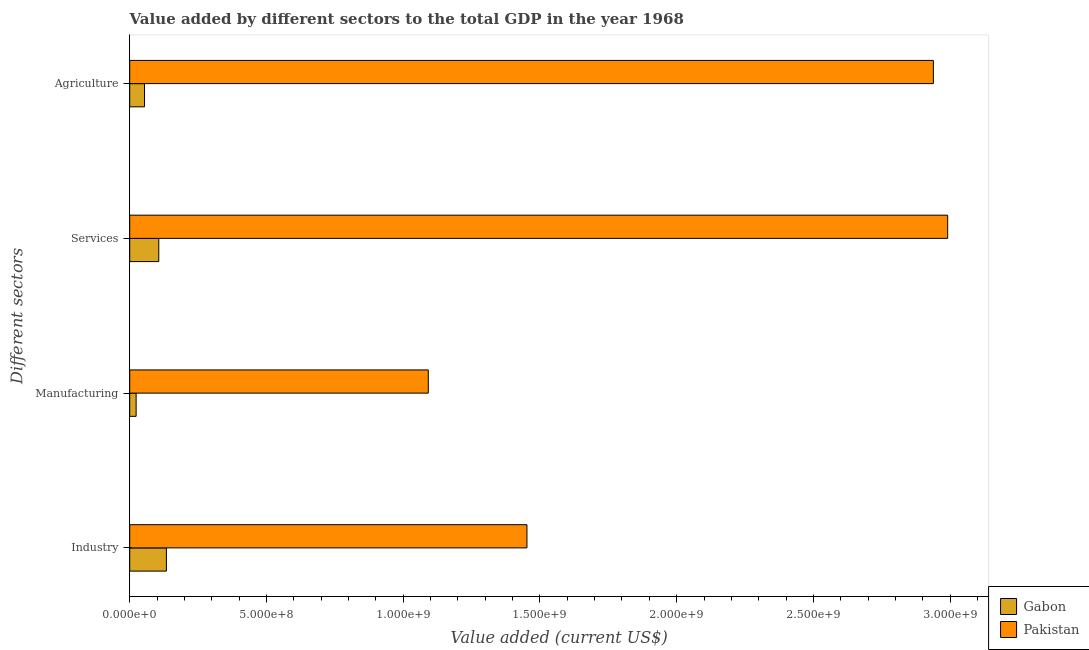How many different coloured bars are there?
Offer a very short reply. 2. Are the number of bars per tick equal to the number of legend labels?
Keep it short and to the point. Yes. Are the number of bars on each tick of the Y-axis equal?
Make the answer very short. Yes. How many bars are there on the 4th tick from the top?
Your answer should be compact. 2. How many bars are there on the 2nd tick from the bottom?
Provide a short and direct response. 2. What is the label of the 1st group of bars from the top?
Your answer should be compact. Agriculture. What is the value added by manufacturing sector in Pakistan?
Your answer should be compact. 1.09e+09. Across all countries, what is the maximum value added by agricultural sector?
Your answer should be compact. 2.94e+09. Across all countries, what is the minimum value added by manufacturing sector?
Provide a succinct answer. 2.34e+07. In which country was the value added by agricultural sector maximum?
Make the answer very short. Pakistan. In which country was the value added by agricultural sector minimum?
Provide a short and direct response. Gabon. What is the total value added by agricultural sector in the graph?
Offer a terse response. 2.99e+09. What is the difference between the value added by manufacturing sector in Gabon and that in Pakistan?
Provide a succinct answer. -1.07e+09. What is the difference between the value added by services sector in Gabon and the value added by industrial sector in Pakistan?
Provide a short and direct response. -1.35e+09. What is the average value added by services sector per country?
Make the answer very short. 1.55e+09. What is the difference between the value added by agricultural sector and value added by manufacturing sector in Gabon?
Provide a short and direct response. 3.07e+07. What is the ratio of the value added by services sector in Pakistan to that in Gabon?
Offer a very short reply. 28.15. Is the difference between the value added by industrial sector in Gabon and Pakistan greater than the difference between the value added by agricultural sector in Gabon and Pakistan?
Offer a terse response. Yes. What is the difference between the highest and the second highest value added by industrial sector?
Offer a terse response. 1.32e+09. What is the difference between the highest and the lowest value added by services sector?
Your answer should be very brief. 2.88e+09. In how many countries, is the value added by manufacturing sector greater than the average value added by manufacturing sector taken over all countries?
Ensure brevity in your answer.  1. What does the 2nd bar from the top in Manufacturing represents?
Provide a succinct answer. Gabon. What does the 2nd bar from the bottom in Industry represents?
Your answer should be compact. Pakistan. Is it the case that in every country, the sum of the value added by industrial sector and value added by manufacturing sector is greater than the value added by services sector?
Your answer should be very brief. No. How many countries are there in the graph?
Provide a short and direct response. 2. Does the graph contain any zero values?
Ensure brevity in your answer.  No. How many legend labels are there?
Offer a very short reply. 2. What is the title of the graph?
Provide a succinct answer. Value added by different sectors to the total GDP in the year 1968. What is the label or title of the X-axis?
Give a very brief answer. Value added (current US$). What is the label or title of the Y-axis?
Your answer should be compact. Different sectors. What is the Value added (current US$) in Gabon in Industry?
Keep it short and to the point. 1.34e+08. What is the Value added (current US$) of Pakistan in Industry?
Offer a very short reply. 1.45e+09. What is the Value added (current US$) of Gabon in Manufacturing?
Ensure brevity in your answer.  2.34e+07. What is the Value added (current US$) in Pakistan in Manufacturing?
Make the answer very short. 1.09e+09. What is the Value added (current US$) in Gabon in Services?
Keep it short and to the point. 1.06e+08. What is the Value added (current US$) of Pakistan in Services?
Ensure brevity in your answer.  2.99e+09. What is the Value added (current US$) of Gabon in Agriculture?
Provide a short and direct response. 5.41e+07. What is the Value added (current US$) of Pakistan in Agriculture?
Make the answer very short. 2.94e+09. Across all Different sectors, what is the maximum Value added (current US$) in Gabon?
Your response must be concise. 1.34e+08. Across all Different sectors, what is the maximum Value added (current US$) in Pakistan?
Your answer should be very brief. 2.99e+09. Across all Different sectors, what is the minimum Value added (current US$) of Gabon?
Make the answer very short. 2.34e+07. Across all Different sectors, what is the minimum Value added (current US$) in Pakistan?
Keep it short and to the point. 1.09e+09. What is the total Value added (current US$) in Gabon in the graph?
Offer a very short reply. 3.18e+08. What is the total Value added (current US$) in Pakistan in the graph?
Your answer should be very brief. 8.47e+09. What is the difference between the Value added (current US$) in Gabon in Industry and that in Manufacturing?
Your answer should be compact. 1.11e+08. What is the difference between the Value added (current US$) in Pakistan in Industry and that in Manufacturing?
Give a very brief answer. 3.61e+08. What is the difference between the Value added (current US$) in Gabon in Industry and that in Services?
Keep it short and to the point. 2.79e+07. What is the difference between the Value added (current US$) of Pakistan in Industry and that in Services?
Provide a short and direct response. -1.54e+09. What is the difference between the Value added (current US$) in Gabon in Industry and that in Agriculture?
Your answer should be very brief. 8.00e+07. What is the difference between the Value added (current US$) of Pakistan in Industry and that in Agriculture?
Provide a short and direct response. -1.49e+09. What is the difference between the Value added (current US$) of Gabon in Manufacturing and that in Services?
Keep it short and to the point. -8.28e+07. What is the difference between the Value added (current US$) of Pakistan in Manufacturing and that in Services?
Provide a succinct answer. -1.90e+09. What is the difference between the Value added (current US$) of Gabon in Manufacturing and that in Agriculture?
Provide a succinct answer. -3.07e+07. What is the difference between the Value added (current US$) in Pakistan in Manufacturing and that in Agriculture?
Provide a short and direct response. -1.85e+09. What is the difference between the Value added (current US$) of Gabon in Services and that in Agriculture?
Your answer should be compact. 5.21e+07. What is the difference between the Value added (current US$) in Pakistan in Services and that in Agriculture?
Provide a succinct answer. 5.23e+07. What is the difference between the Value added (current US$) in Gabon in Industry and the Value added (current US$) in Pakistan in Manufacturing?
Provide a short and direct response. -9.58e+08. What is the difference between the Value added (current US$) in Gabon in Industry and the Value added (current US$) in Pakistan in Services?
Your response must be concise. -2.86e+09. What is the difference between the Value added (current US$) in Gabon in Industry and the Value added (current US$) in Pakistan in Agriculture?
Your answer should be compact. -2.80e+09. What is the difference between the Value added (current US$) in Gabon in Manufacturing and the Value added (current US$) in Pakistan in Services?
Provide a succinct answer. -2.97e+09. What is the difference between the Value added (current US$) of Gabon in Manufacturing and the Value added (current US$) of Pakistan in Agriculture?
Make the answer very short. -2.92e+09. What is the difference between the Value added (current US$) in Gabon in Services and the Value added (current US$) in Pakistan in Agriculture?
Give a very brief answer. -2.83e+09. What is the average Value added (current US$) of Gabon per Different sectors?
Give a very brief answer. 7.95e+07. What is the average Value added (current US$) of Pakistan per Different sectors?
Keep it short and to the point. 2.12e+09. What is the difference between the Value added (current US$) in Gabon and Value added (current US$) in Pakistan in Industry?
Provide a succinct answer. -1.32e+09. What is the difference between the Value added (current US$) of Gabon and Value added (current US$) of Pakistan in Manufacturing?
Provide a succinct answer. -1.07e+09. What is the difference between the Value added (current US$) in Gabon and Value added (current US$) in Pakistan in Services?
Offer a very short reply. -2.88e+09. What is the difference between the Value added (current US$) of Gabon and Value added (current US$) of Pakistan in Agriculture?
Your answer should be compact. -2.88e+09. What is the ratio of the Value added (current US$) in Gabon in Industry to that in Manufacturing?
Your answer should be very brief. 5.72. What is the ratio of the Value added (current US$) of Pakistan in Industry to that in Manufacturing?
Your answer should be very brief. 1.33. What is the ratio of the Value added (current US$) of Gabon in Industry to that in Services?
Make the answer very short. 1.26. What is the ratio of the Value added (current US$) in Pakistan in Industry to that in Services?
Your answer should be compact. 0.49. What is the ratio of the Value added (current US$) in Gabon in Industry to that in Agriculture?
Provide a short and direct response. 2.48. What is the ratio of the Value added (current US$) of Pakistan in Industry to that in Agriculture?
Provide a succinct answer. 0.49. What is the ratio of the Value added (current US$) in Gabon in Manufacturing to that in Services?
Provide a succinct answer. 0.22. What is the ratio of the Value added (current US$) in Pakistan in Manufacturing to that in Services?
Provide a short and direct response. 0.36. What is the ratio of the Value added (current US$) in Gabon in Manufacturing to that in Agriculture?
Your response must be concise. 0.43. What is the ratio of the Value added (current US$) of Pakistan in Manufacturing to that in Agriculture?
Offer a terse response. 0.37. What is the ratio of the Value added (current US$) of Gabon in Services to that in Agriculture?
Your answer should be very brief. 1.96. What is the ratio of the Value added (current US$) in Pakistan in Services to that in Agriculture?
Offer a very short reply. 1.02. What is the difference between the highest and the second highest Value added (current US$) in Gabon?
Your answer should be very brief. 2.79e+07. What is the difference between the highest and the second highest Value added (current US$) in Pakistan?
Keep it short and to the point. 5.23e+07. What is the difference between the highest and the lowest Value added (current US$) in Gabon?
Offer a terse response. 1.11e+08. What is the difference between the highest and the lowest Value added (current US$) in Pakistan?
Offer a very short reply. 1.90e+09. 